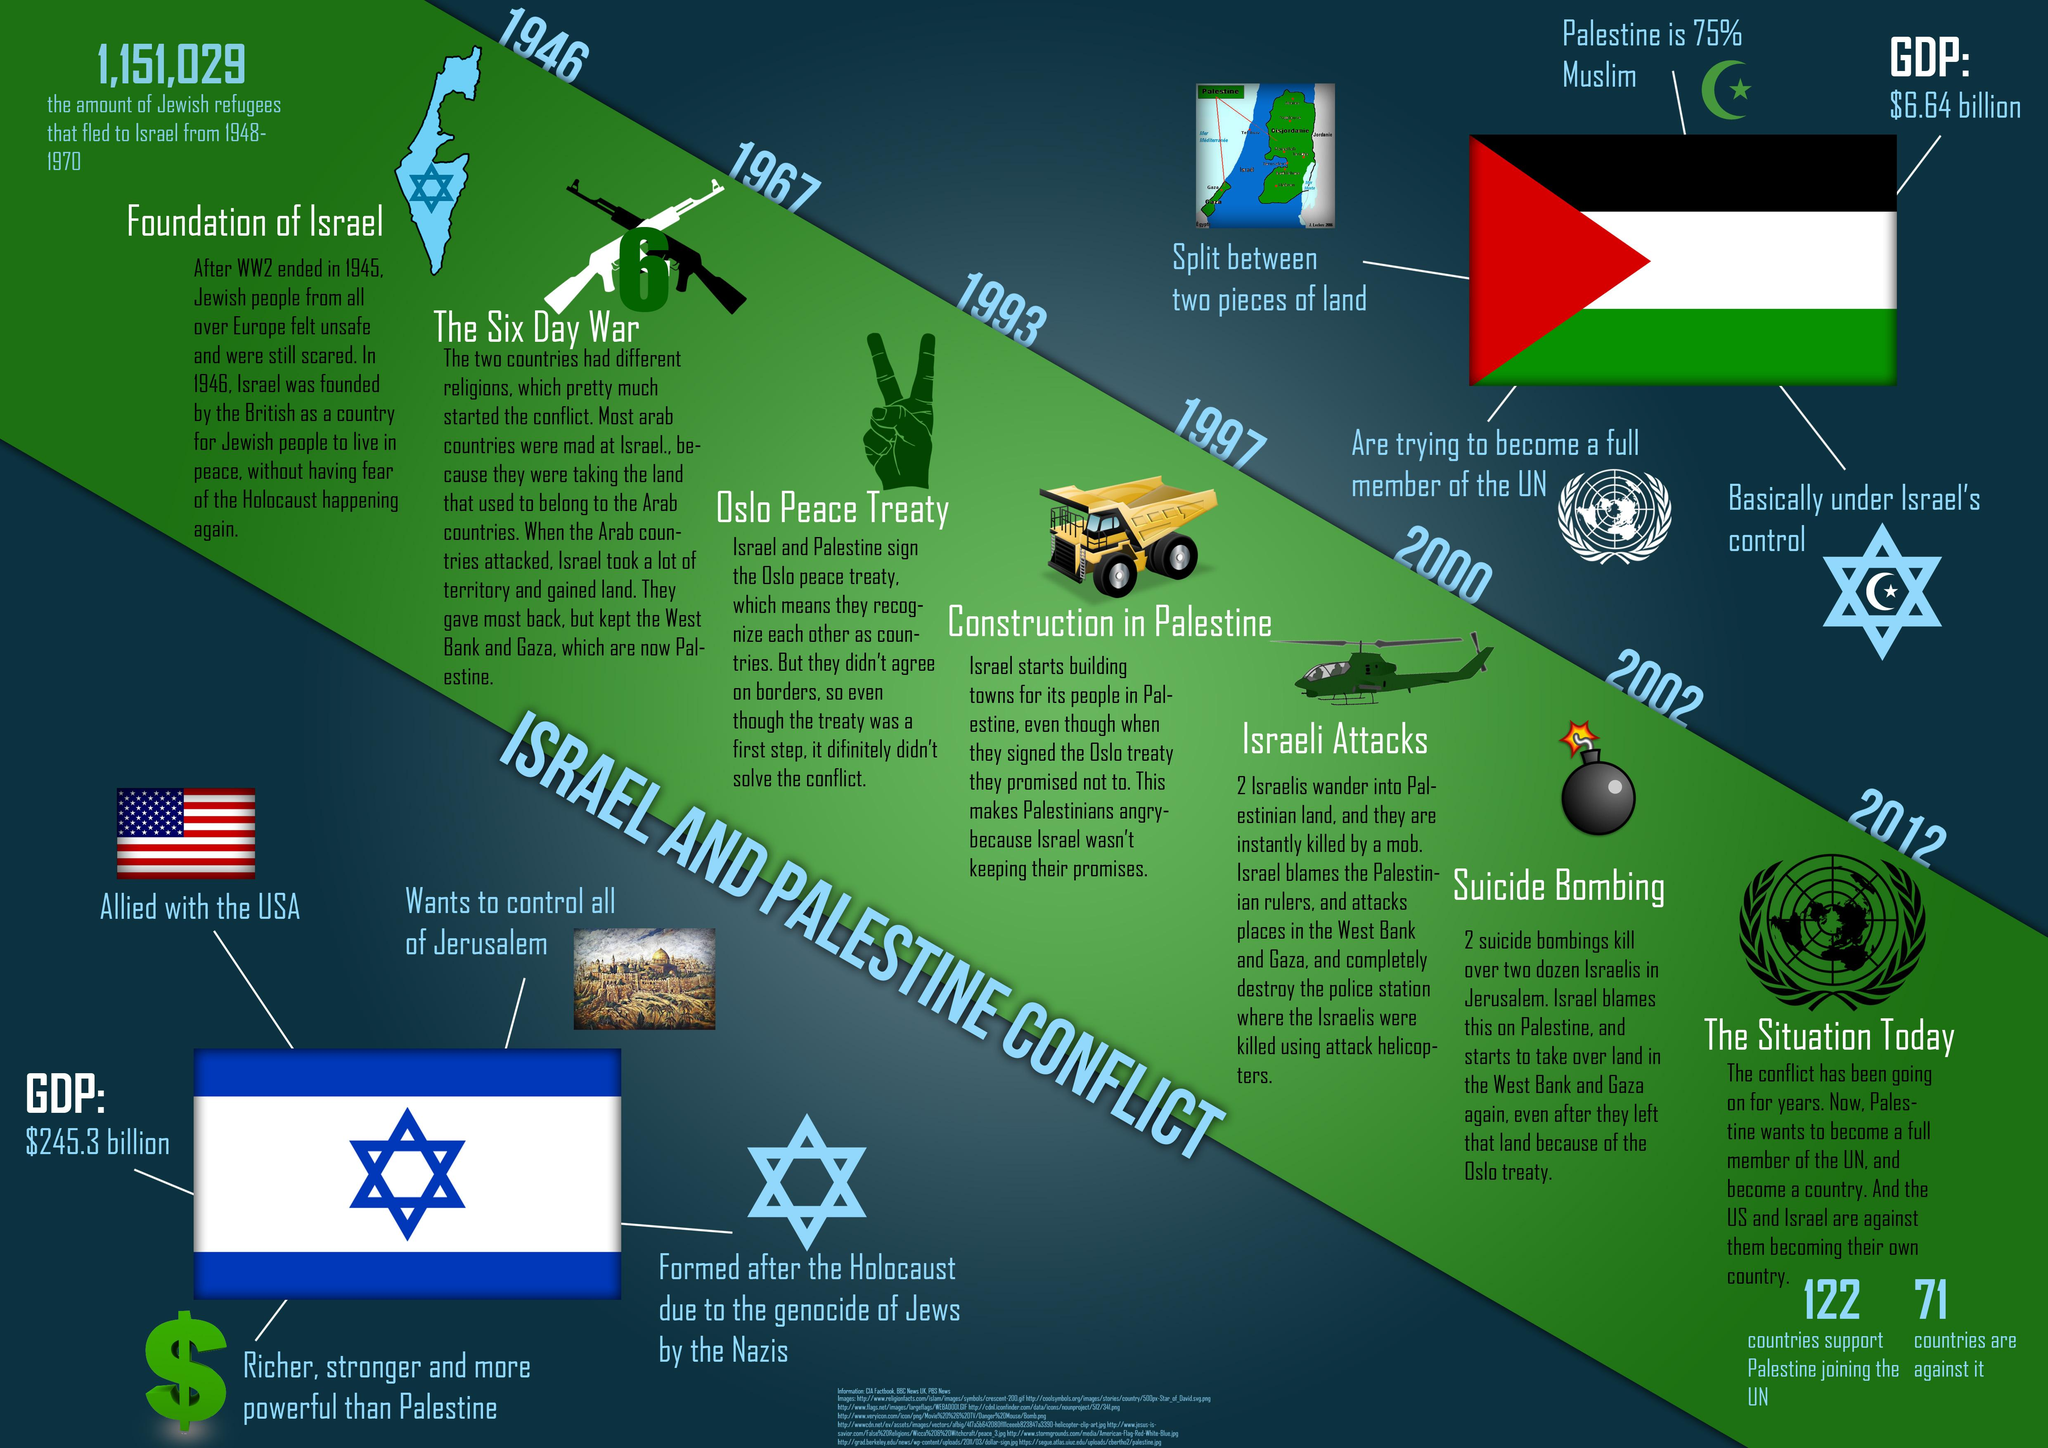List a handful of essential elements in this visual. The infamous "Suicide Bombing" took place in the year 2002. There are 122 nations that support Palestine's bid to join the United Nations. Seventy-one countries do not support Palestine's application to join the United Nations. The Oslo Peace Treaty was signed in 1993. 